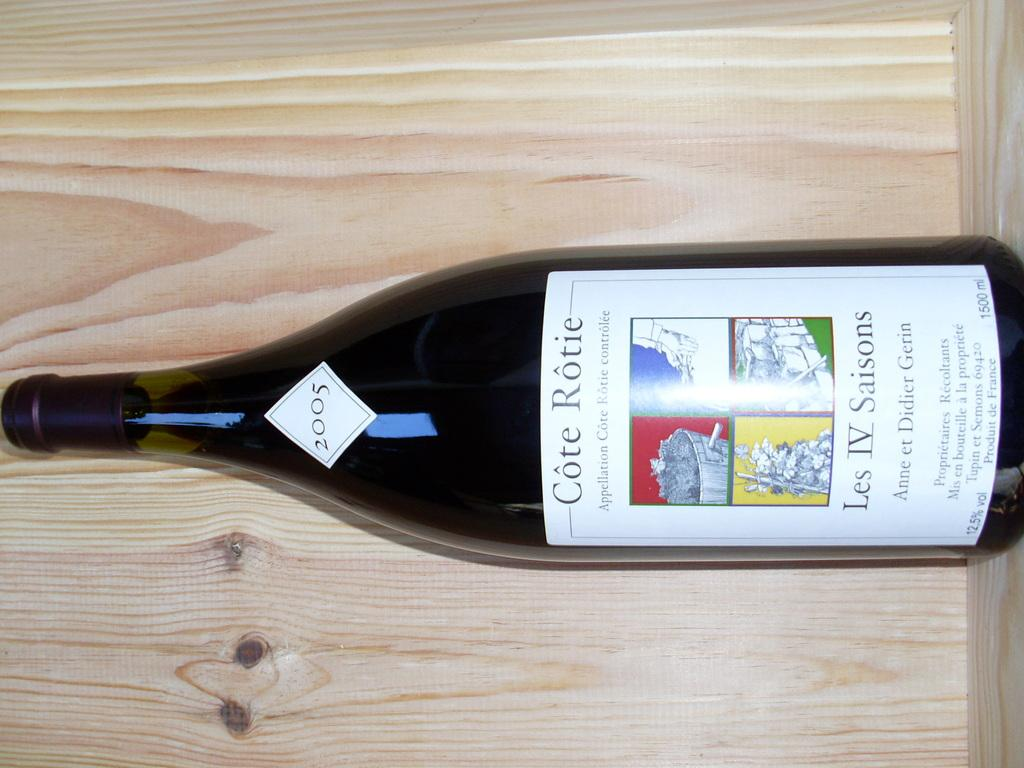What object can be seen in the image? There is a bottle in the image. What is the color of the bottle? The bottle is black in color. On what surface is the bottle placed? The bottle is on a cream-colored surface. How does the cat push the bottle in the image? There is no cat present in the image, so it cannot push the bottle. 